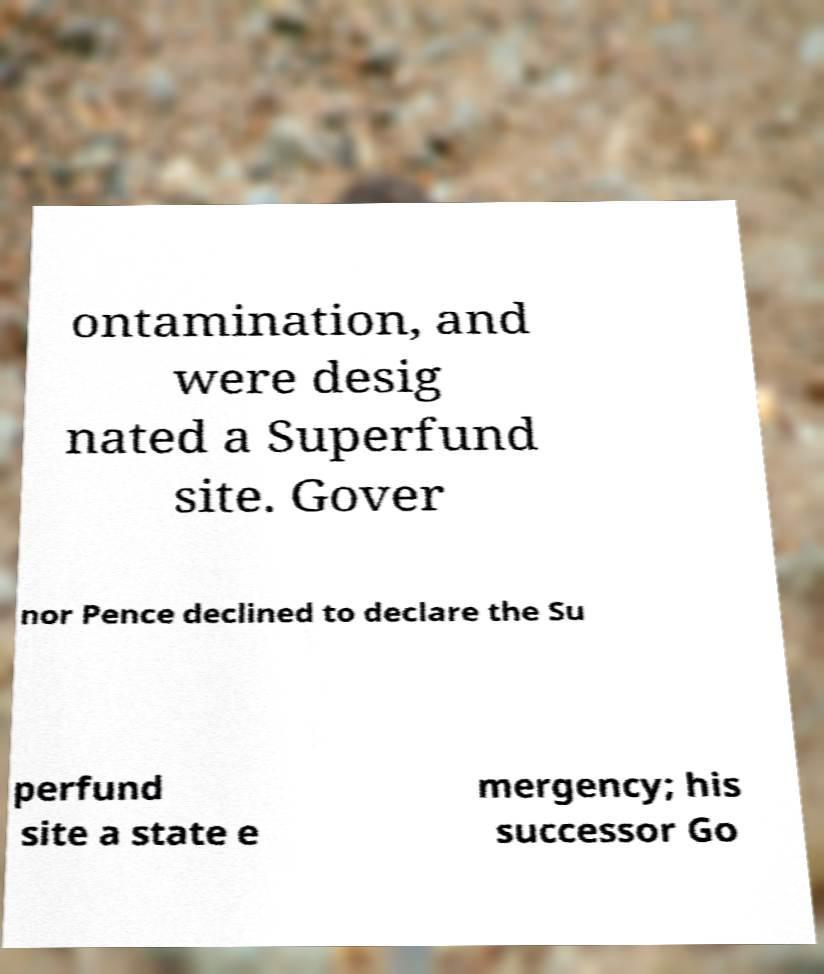Could you extract and type out the text from this image? ontamination, and were desig nated a Superfund site. Gover nor Pence declined to declare the Su perfund site a state e mergency; his successor Go 